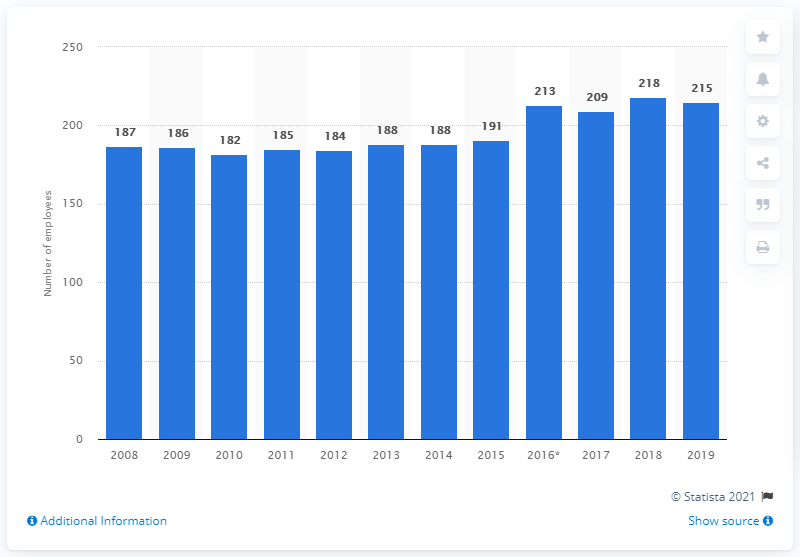Specify some key components in this picture. In 2018, there were 218 general practitioners employed in Iceland, the highest number on record. 